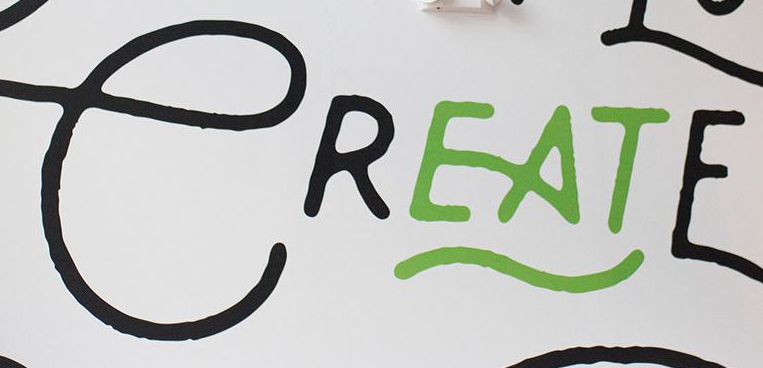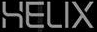What text is displayed in these images sequentially, separated by a semicolon? CREATE; HELIX 